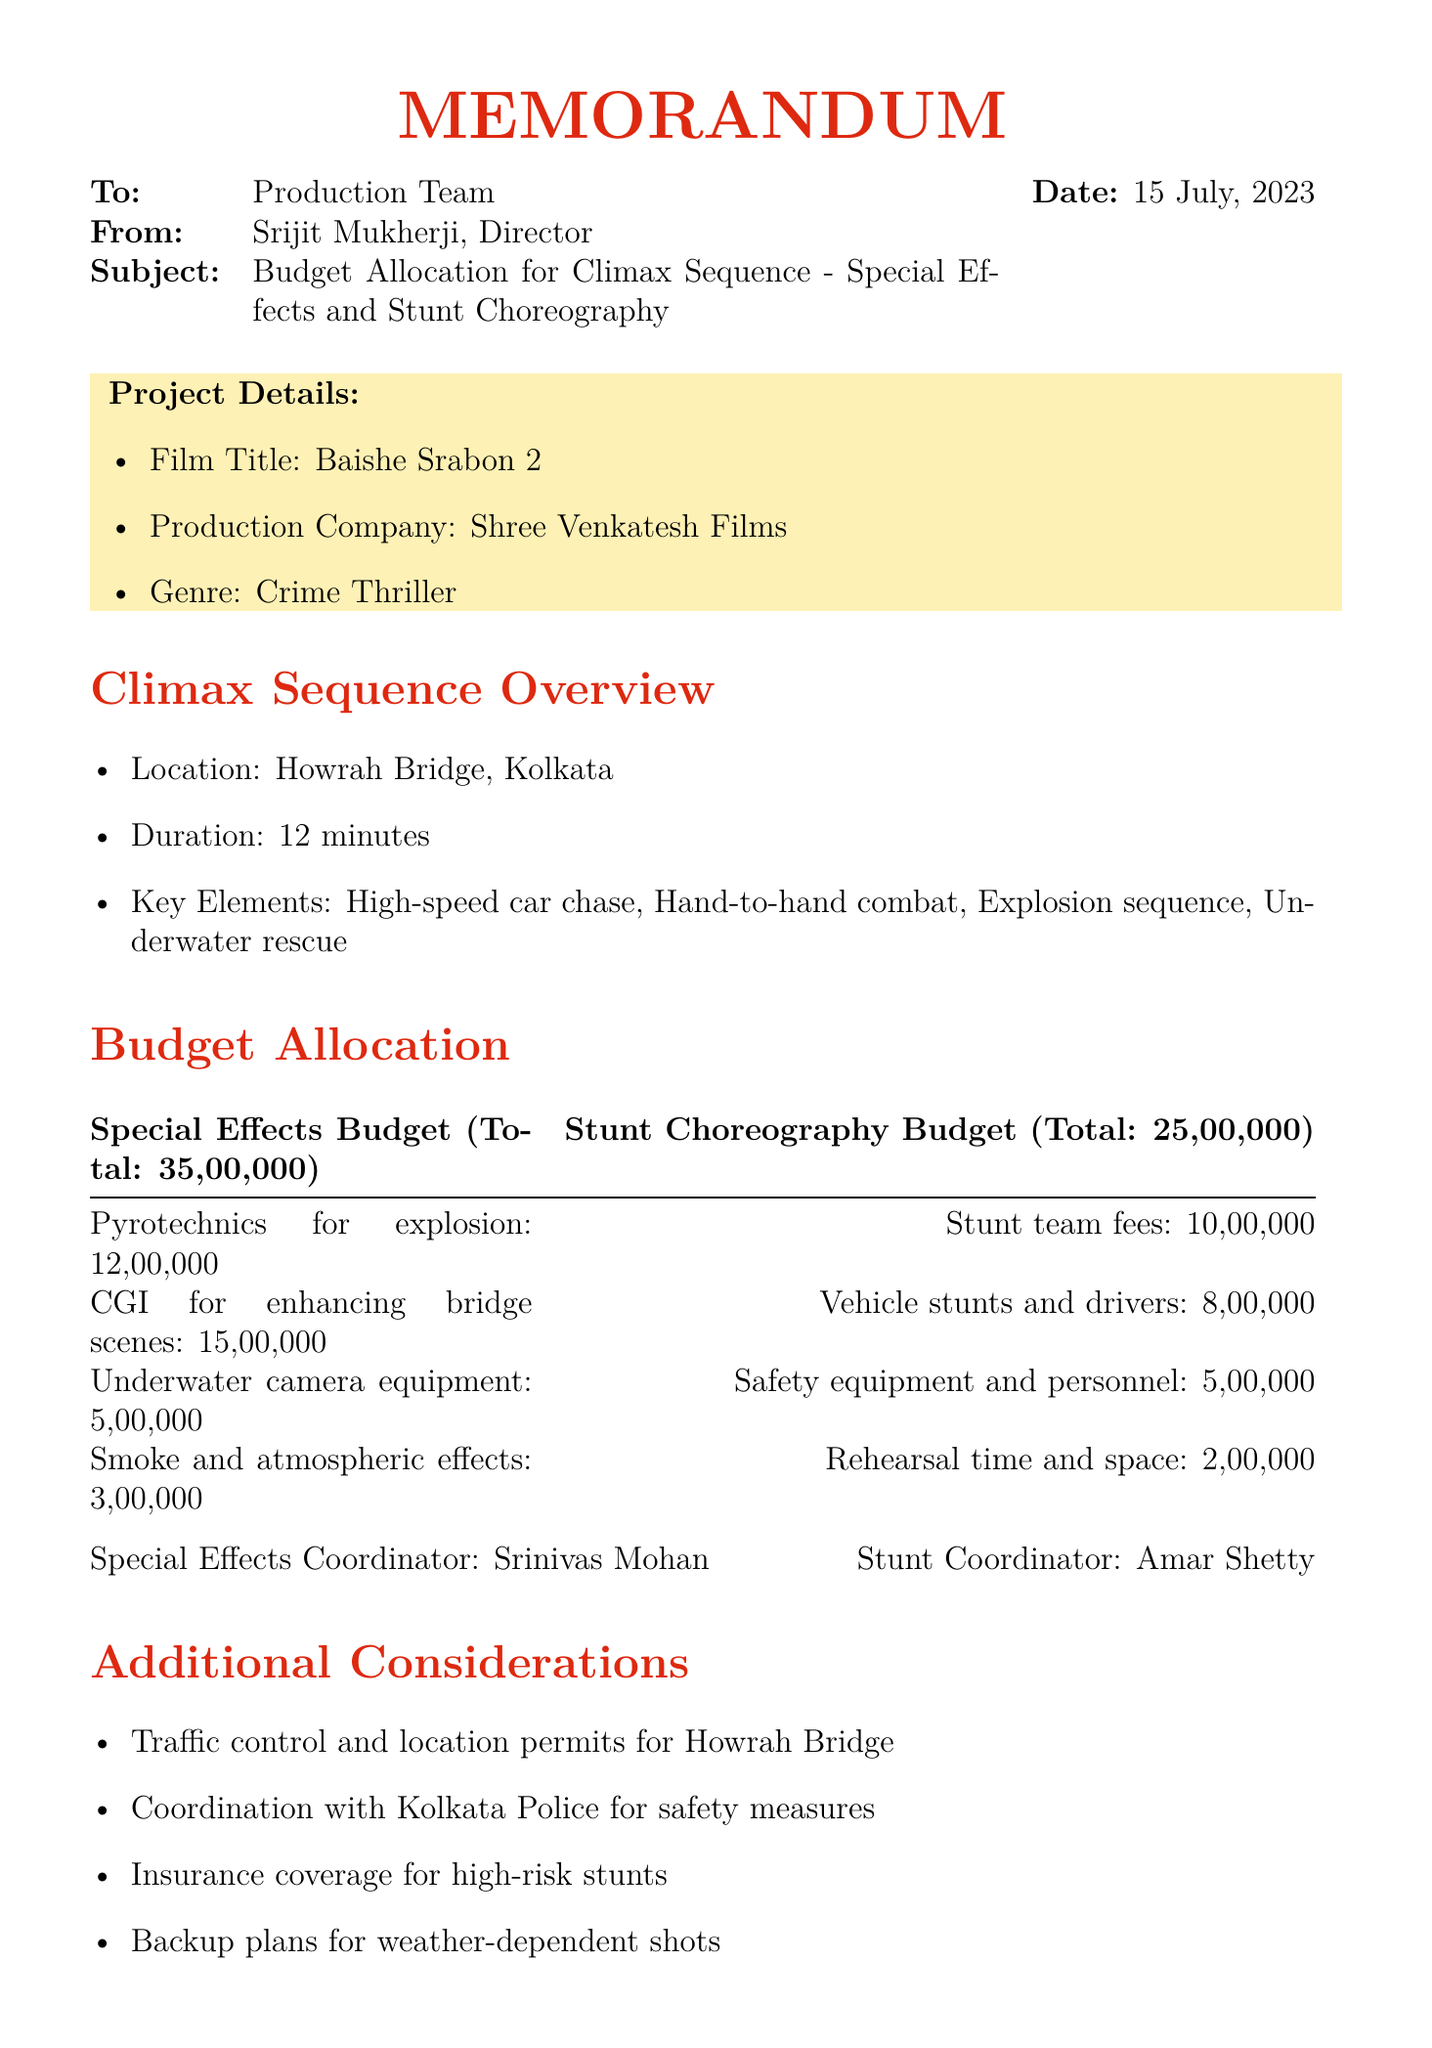What is the total allocation for special effects? The total allocation for special effects is specified in the budget section of the document.
Answer: ₹35,00,000 Who is the special effects coordinator? The name of the special effects coordinator is mentioned in the budget section.
Answer: Srinivas Mohan What is the location of the climax sequence? The location is stated in the overview of the climax sequence.
Answer: Howrah Bridge, Kolkata What is the budget for stunt team fees? The budget breakdown includes specific costs for various items, including stunt team fees.
Answer: ₹10,00,000 How many minutes does the climax sequence last? The duration of the climax sequence is mentioned in the overview section.
Answer: 12 minutes Which film is referenced for high-octane action sequences? The reference films section lists films that serve as examples for specific elements.
Answer: Dhoom 3 (2013) What additional consideration involves the Kolkata Police? Additional considerations include various logistical and safety measures for the shoot.
Answer: Coordination with Kolkata Police for safety measures Who needs to approve the budget allocation? The document specifies individuals who need to approve the allocation.
Answer: Shrikant Mohta, Mahendra Soni, Soumik Halder 